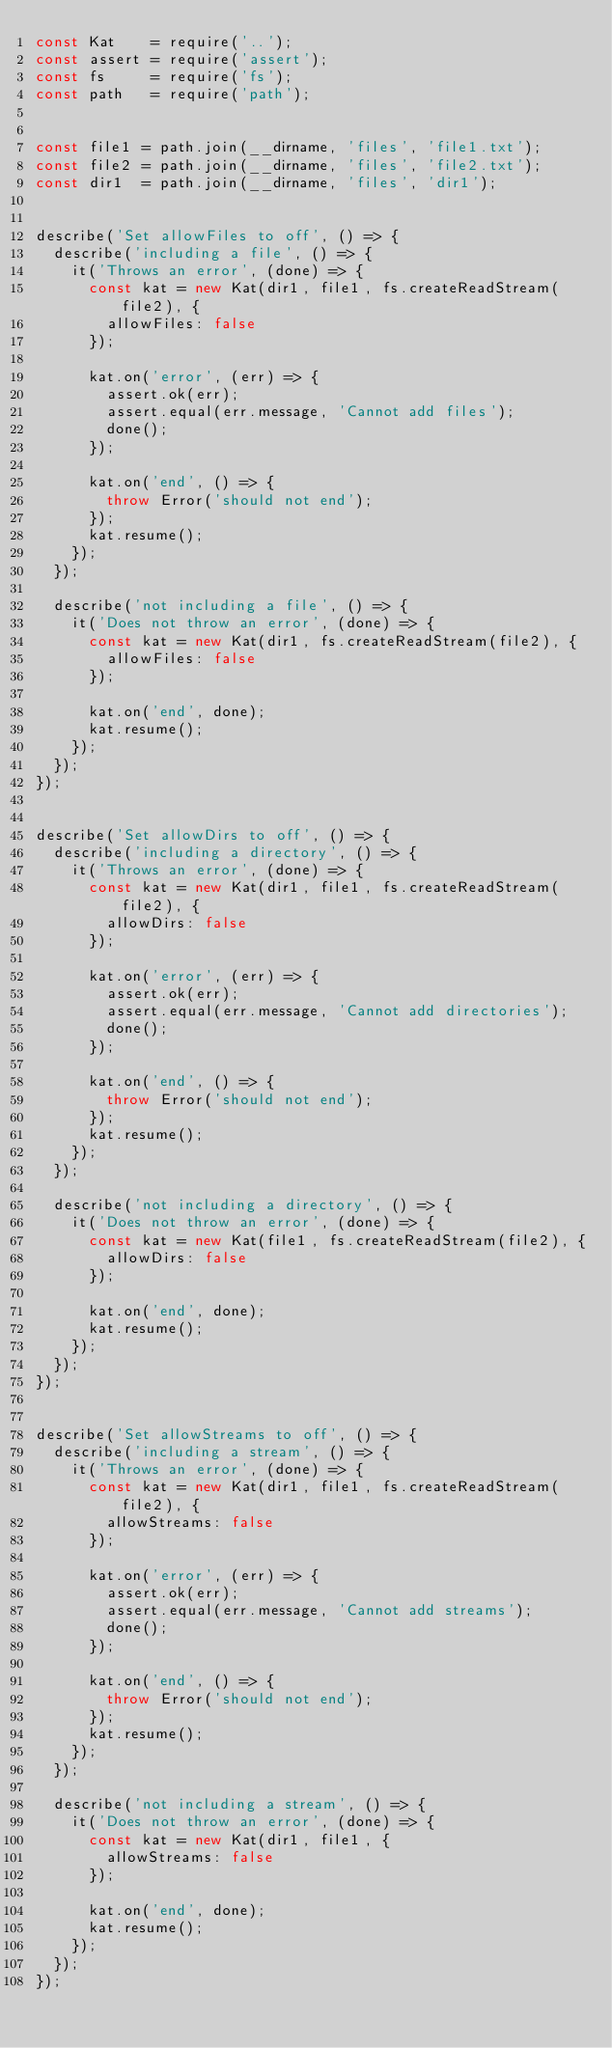Convert code to text. <code><loc_0><loc_0><loc_500><loc_500><_JavaScript_>const Kat    = require('..');
const assert = require('assert');
const fs     = require('fs');
const path   = require('path');


const file1 = path.join(__dirname, 'files', 'file1.txt');
const file2 = path.join(__dirname, 'files', 'file2.txt');
const dir1  = path.join(__dirname, 'files', 'dir1');


describe('Set allowFiles to off', () => {
  describe('including a file', () => {
    it('Throws an error', (done) => {
      const kat = new Kat(dir1, file1, fs.createReadStream(file2), {
        allowFiles: false
      });

      kat.on('error', (err) => {
        assert.ok(err);
        assert.equal(err.message, 'Cannot add files');
        done();
      });

      kat.on('end', () => {
        throw Error('should not end');
      });
      kat.resume();
    });
  });

  describe('not including a file', () => {
    it('Does not throw an error', (done) => {
      const kat = new Kat(dir1, fs.createReadStream(file2), {
        allowFiles: false
      });

      kat.on('end', done);
      kat.resume();
    });
  });
});


describe('Set allowDirs to off', () => {
  describe('including a directory', () => {
    it('Throws an error', (done) => {
      const kat = new Kat(dir1, file1, fs.createReadStream(file2), {
        allowDirs: false
      });

      kat.on('error', (err) => {
        assert.ok(err);
        assert.equal(err.message, 'Cannot add directories');
        done();
      });

      kat.on('end', () => {
        throw Error('should not end');
      });
      kat.resume();
    });
  });

  describe('not including a directory', () => {
    it('Does not throw an error', (done) => {
      const kat = new Kat(file1, fs.createReadStream(file2), {
        allowDirs: false
      });

      kat.on('end', done);
      kat.resume();
    });
  });
});


describe('Set allowStreams to off', () => {
  describe('including a stream', () => {
    it('Throws an error', (done) => {
      const kat = new Kat(dir1, file1, fs.createReadStream(file2), {
        allowStreams: false
      });

      kat.on('error', (err) => {
        assert.ok(err);
        assert.equal(err.message, 'Cannot add streams');
        done();
      });

      kat.on('end', () => {
        throw Error('should not end');
      });
      kat.resume();
    });
  });

  describe('not including a stream', () => {
    it('Does not throw an error', (done) => {
      const kat = new Kat(dir1, file1, {
        allowStreams: false
      });

      kat.on('end', done);
      kat.resume();
    });
  });
});
</code> 